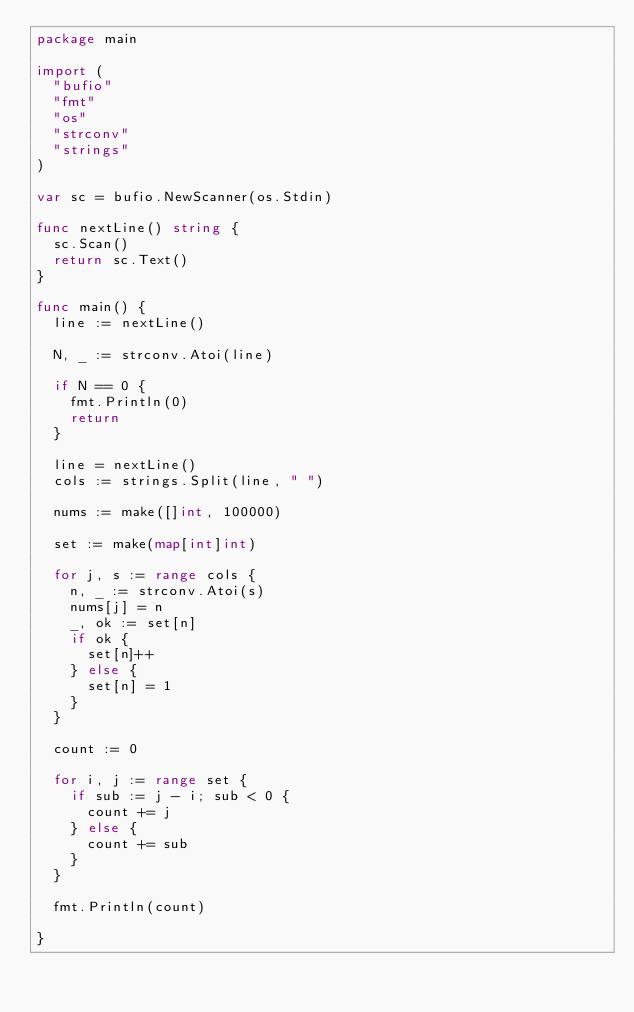<code> <loc_0><loc_0><loc_500><loc_500><_Go_>package main
 
import (
	"bufio"
	"fmt"
	"os"
	"strconv"
	"strings"
)
 
var sc = bufio.NewScanner(os.Stdin)
 
func nextLine() string {
	sc.Scan()
	return sc.Text()
}
 
func main() {
	line := nextLine()
 
	N, _ := strconv.Atoi(line)
 
	if N == 0 {
		fmt.Println(0)
		return
	}
 
	line = nextLine()
	cols := strings.Split(line, " ")
 
	nums := make([]int, 100000)
 
	set := make(map[int]int)
 
	for j, s := range cols {
		n, _ := strconv.Atoi(s)
		nums[j] = n
		_, ok := set[n]
		if ok {
			set[n]++
		} else {
			set[n] = 1
		}
	}
 
	count := 0
 
	for i, j := range set {
		if sub := j - i; sub < 0 {
			count += j
		} else {
			count += sub
		}
	}
 
	fmt.Println(count)
 
}</code> 